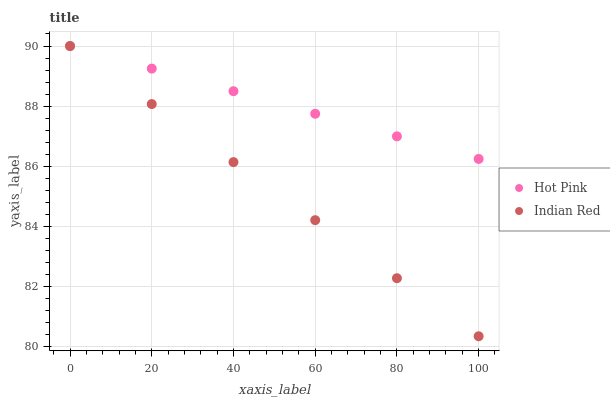Does Indian Red have the minimum area under the curve?
Answer yes or no. Yes. Does Hot Pink have the maximum area under the curve?
Answer yes or no. Yes. Does Indian Red have the maximum area under the curve?
Answer yes or no. No. Is Hot Pink the smoothest?
Answer yes or no. Yes. Is Indian Red the roughest?
Answer yes or no. Yes. Is Indian Red the smoothest?
Answer yes or no. No. Does Indian Red have the lowest value?
Answer yes or no. Yes. Does Indian Red have the highest value?
Answer yes or no. Yes. Does Hot Pink intersect Indian Red?
Answer yes or no. Yes. Is Hot Pink less than Indian Red?
Answer yes or no. No. Is Hot Pink greater than Indian Red?
Answer yes or no. No. 